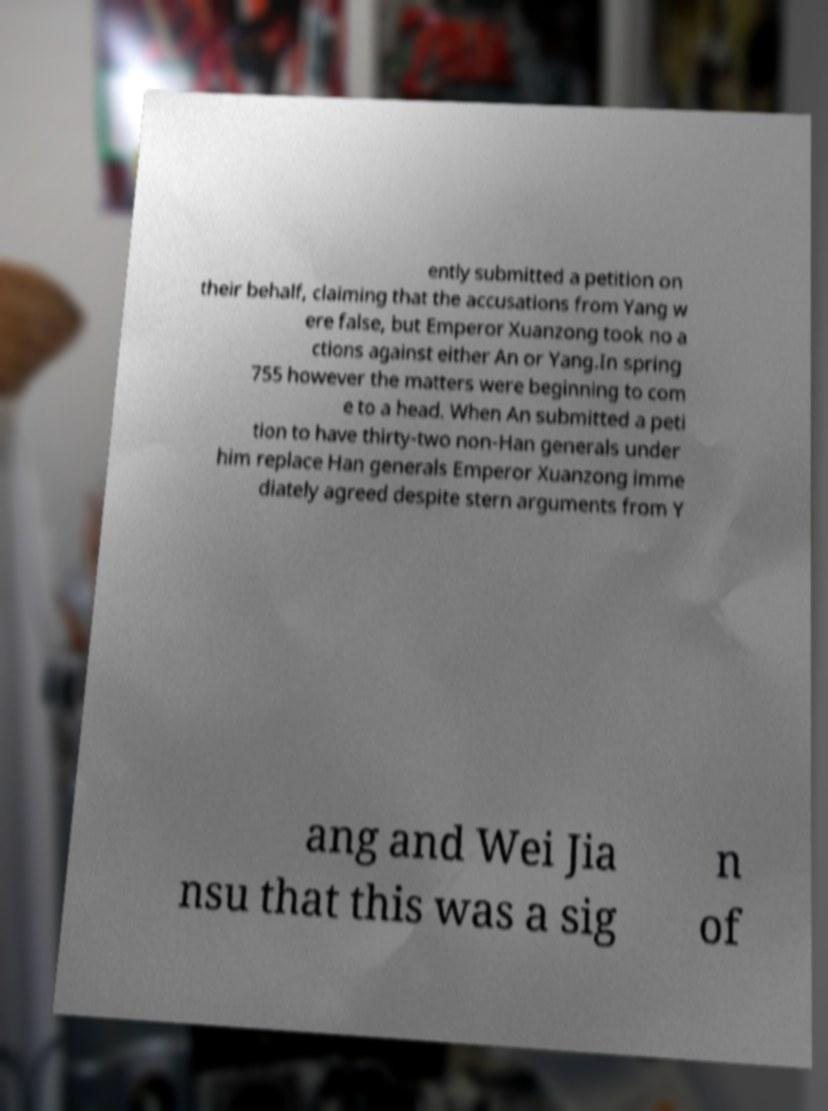Please identify and transcribe the text found in this image. ently submitted a petition on their behalf, claiming that the accusations from Yang w ere false, but Emperor Xuanzong took no a ctions against either An or Yang.In spring 755 however the matters were beginning to com e to a head. When An submitted a peti tion to have thirty-two non-Han generals under him replace Han generals Emperor Xuanzong imme diately agreed despite stern arguments from Y ang and Wei Jia nsu that this was a sig n of 